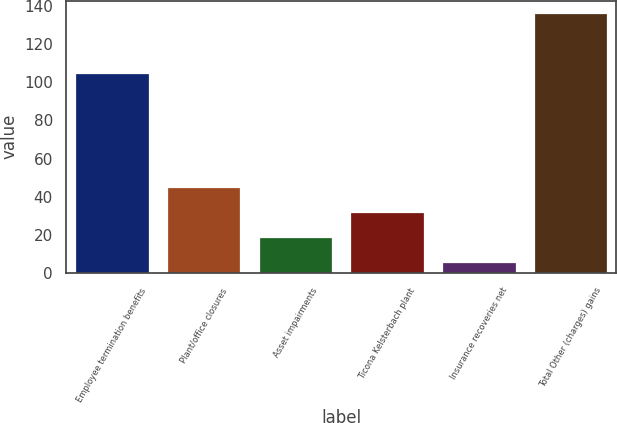Convert chart. <chart><loc_0><loc_0><loc_500><loc_500><bar_chart><fcel>Employee termination benefits<fcel>Plant/office closures<fcel>Asset impairments<fcel>Ticona Kelsterbach plant<fcel>Insurance recoveries net<fcel>Total Other (charges) gains<nl><fcel>105<fcel>45<fcel>19<fcel>32<fcel>6<fcel>136<nl></chart> 